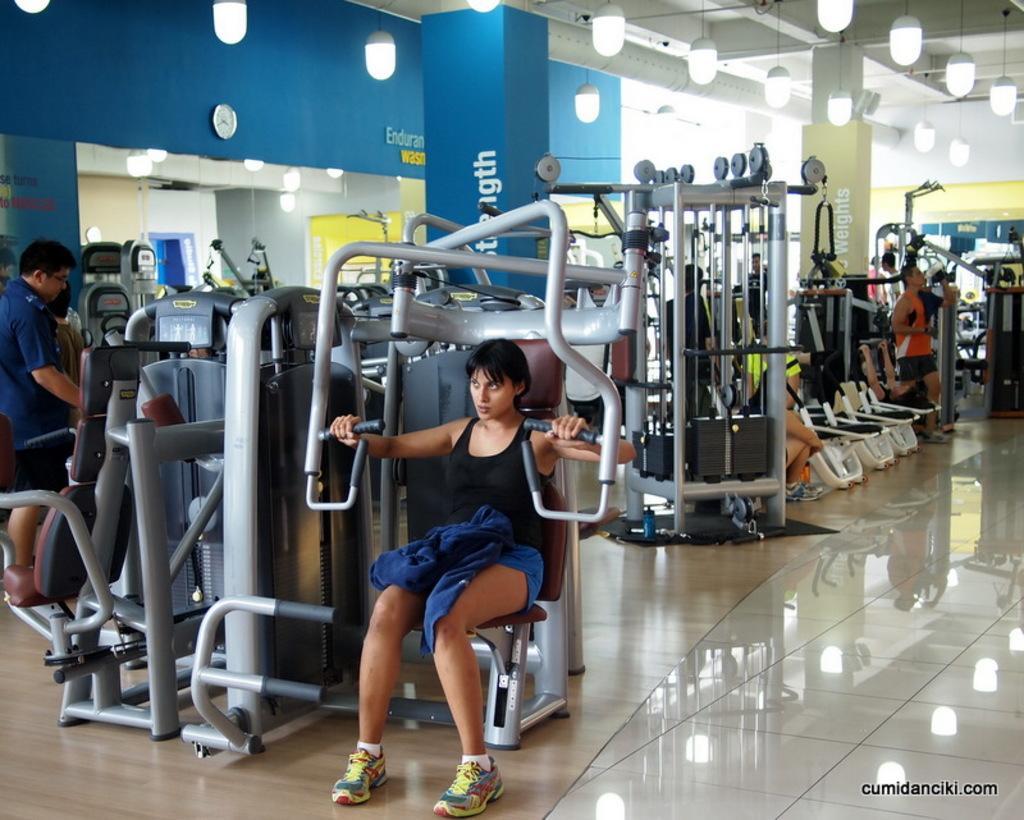Can you describe this image briefly? The picture is taken in a gym. In this picture there are various gym equipment and people. At the top of there are lights to the ceiling. In the background the lights, pillars and a clock. 